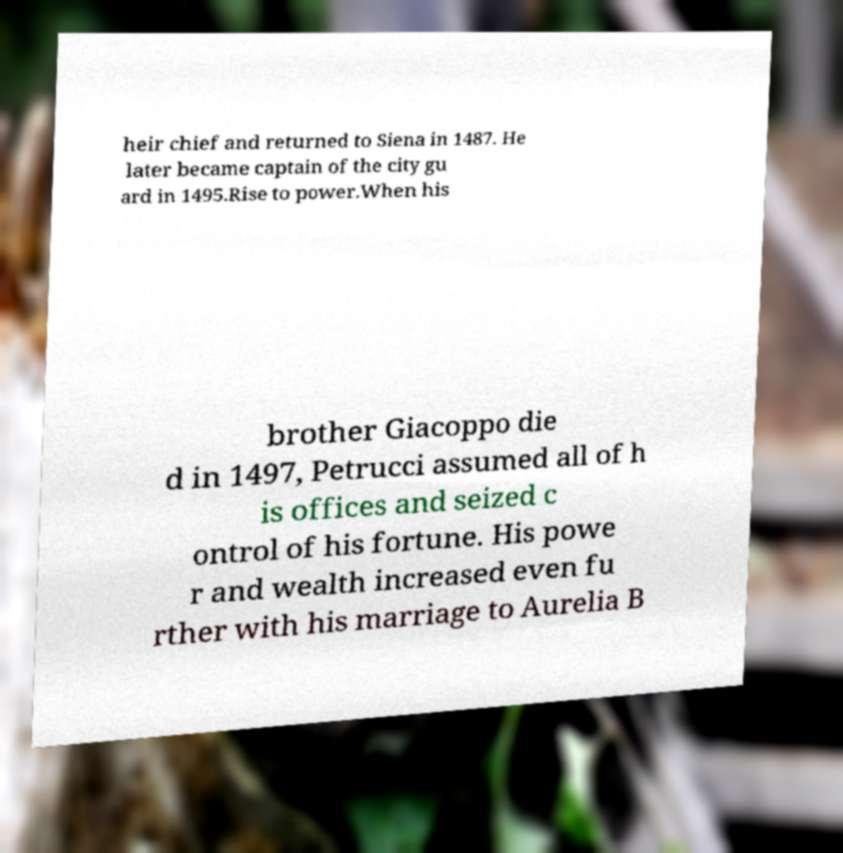Please identify and transcribe the text found in this image. heir chief and returned to Siena in 1487. He later became captain of the city gu ard in 1495.Rise to power.When his brother Giacoppo die d in 1497, Petrucci assumed all of h is offices and seized c ontrol of his fortune. His powe r and wealth increased even fu rther with his marriage to Aurelia B 